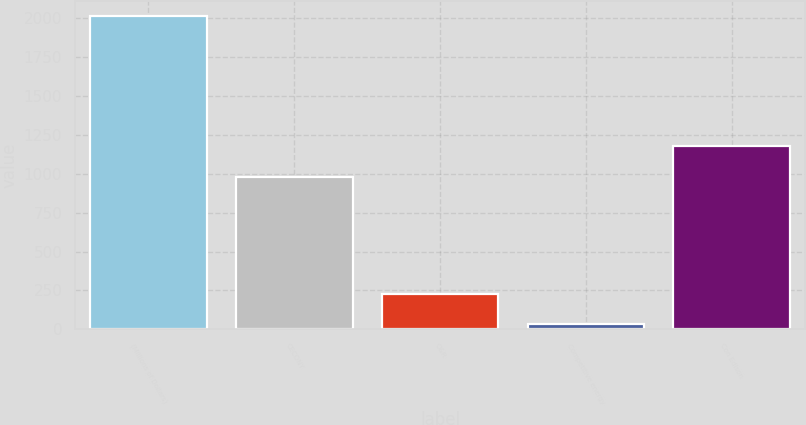Convert chart to OTSL. <chart><loc_0><loc_0><loc_500><loc_500><bar_chart><fcel>(Millions of Dollars)<fcel>CECONY<fcel>O&R<fcel>Competitive energy<fcel>Con Edison<nl><fcel>2011<fcel>978<fcel>229.9<fcel>32<fcel>1175.9<nl></chart> 